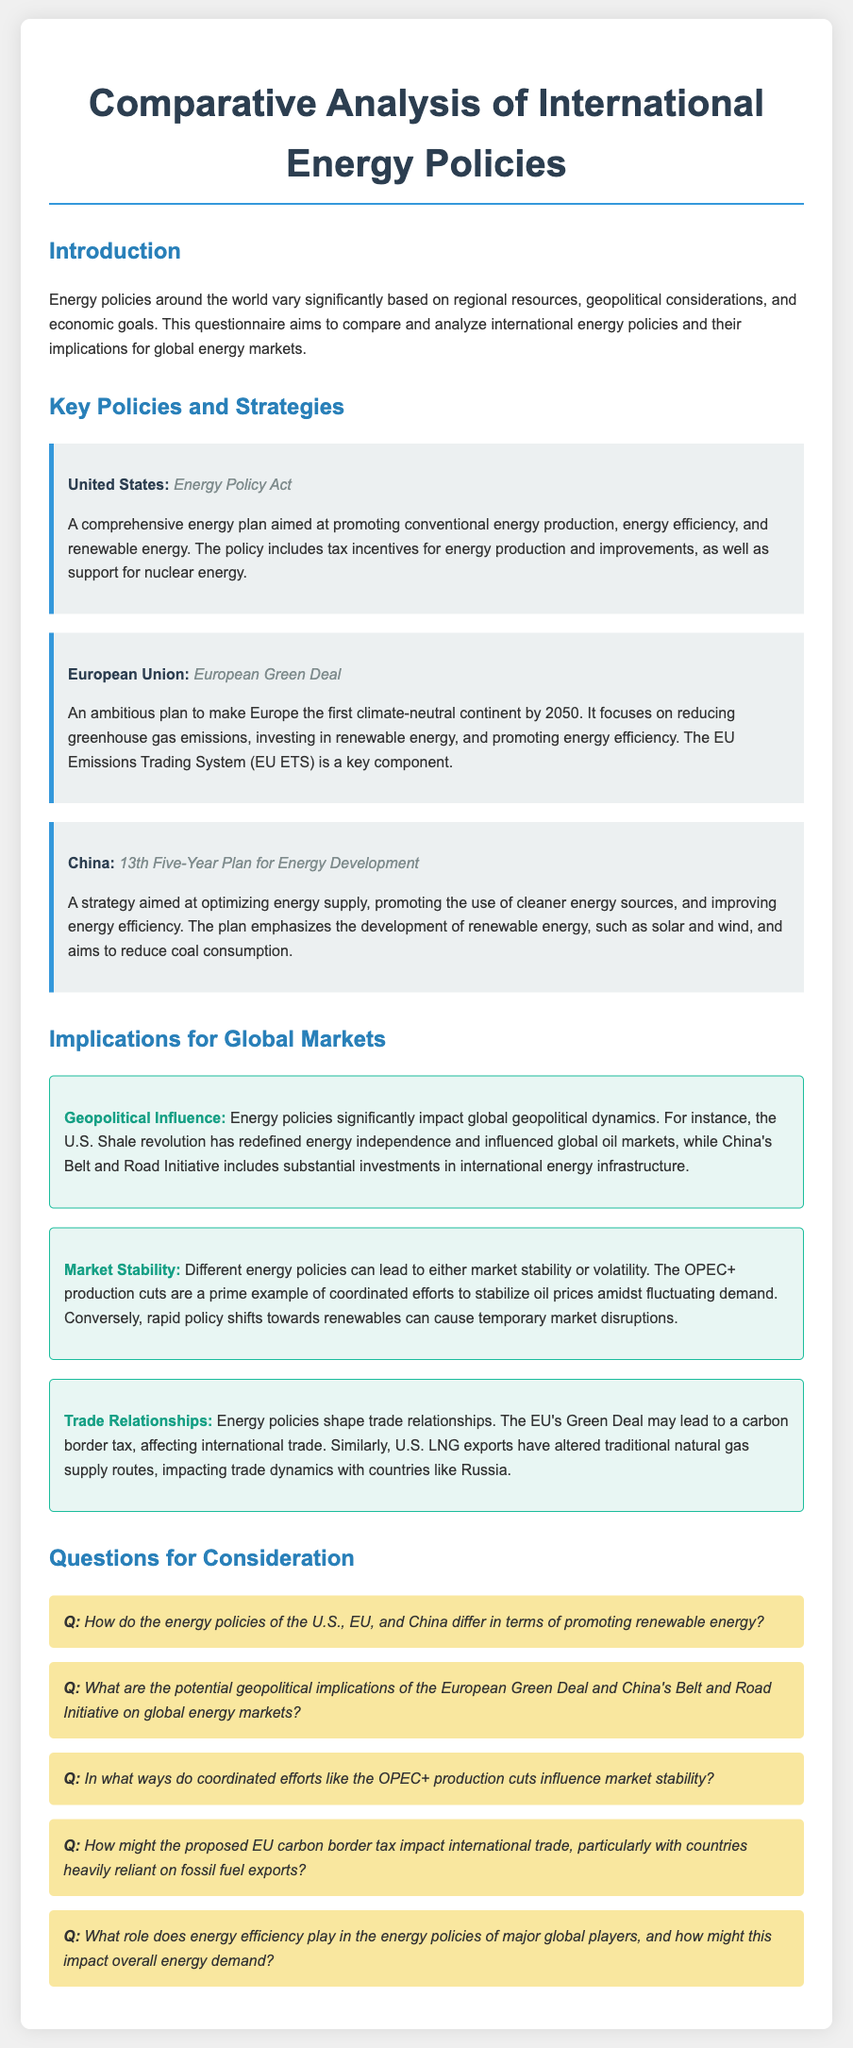What is the name of the U.S. energy policy mentioned? The policy is referred to as the Energy Policy Act.
Answer: Energy Policy Act What is the goal of the European Green Deal? The goal is to make Europe the first climate-neutral continent by 2050.
Answer: climate-neutral continent by 2050 Which country's energy strategy emphasizes reduced coal consumption? The strategy is associated with China.
Answer: China What is a key component of the EU's climate policy? A key component is the EU Emissions Trading System (EU ETS).
Answer: EU Emissions Trading System Which geopolitical initiative is associated with China? The initiative is known as the Belt and Road Initiative.
Answer: Belt and Road Initiative How do coordinated efforts like OPEC+ influence oil prices? They aim to stabilize oil prices amidst fluctuating demand.
Answer: stabilize oil prices What might the EU's proposed carbon border tax affect? It may affect international trade.
Answer: international trade Which aspect of energy policy is emphasized by the U.S., EU, and China? The aspect is promoting renewable energy.
Answer: renewable energy What major consequence does the U.S. Shale revolution have on markets? It redefined energy independence and influenced global oil markets.
Answer: energy independence 